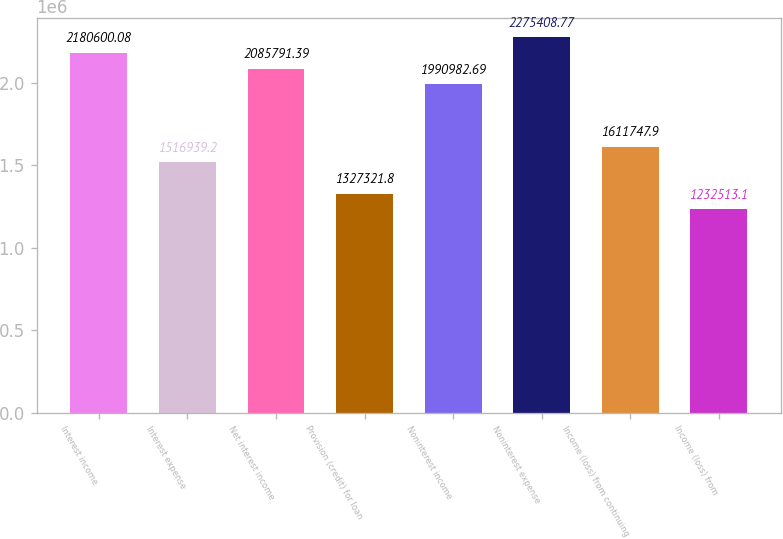<chart> <loc_0><loc_0><loc_500><loc_500><bar_chart><fcel>Interest income<fcel>Interest expense<fcel>Net interest income<fcel>Provision (credit) for loan<fcel>Noninterest income<fcel>Noninterest expense<fcel>Income (loss) from continuing<fcel>Income (loss) from<nl><fcel>2.1806e+06<fcel>1.51694e+06<fcel>2.08579e+06<fcel>1.32732e+06<fcel>1.99098e+06<fcel>2.27541e+06<fcel>1.61175e+06<fcel>1.23251e+06<nl></chart> 